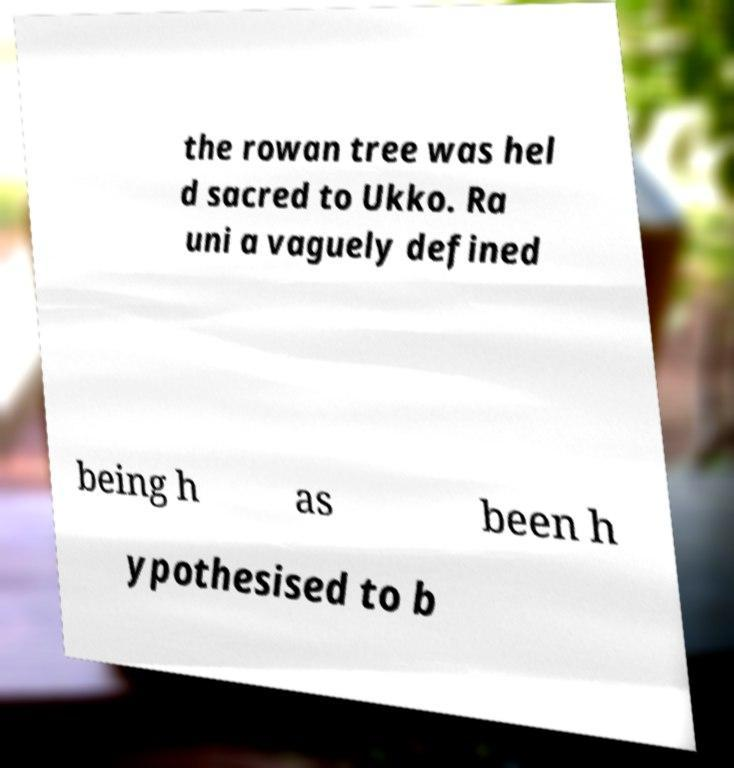Can you read and provide the text displayed in the image?This photo seems to have some interesting text. Can you extract and type it out for me? the rowan tree was hel d sacred to Ukko. Ra uni a vaguely defined being h as been h ypothesised to b 